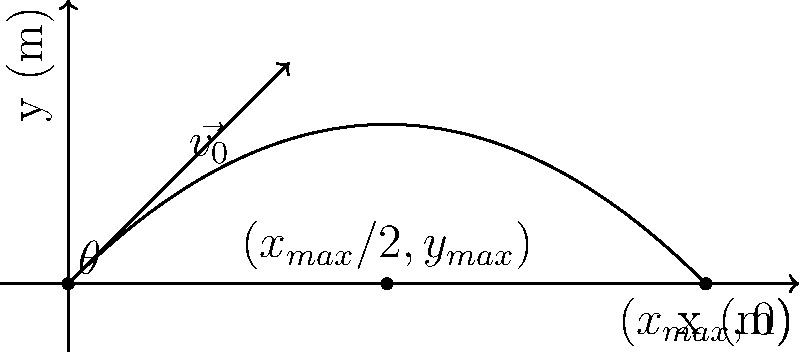A baseball player throws a ball with an initial velocity of 20 m/s at an angle of 45° above the horizontal. Assuming air resistance is negligible, determine:
a) The maximum height reached by the ball
b) The total horizontal distance traveled by the ball

Express your answers in meters, rounded to two decimal places. Let's approach this step-by-step:

1) First, we need to break down the initial velocity into its horizontal and vertical components:
   $v_{0x} = v_0 \cos(\theta) = 20 \cos(45°) = 20 \cdot \frac{\sqrt{2}}{2} \approx 14.14$ m/s
   $v_{0y} = v_0 \sin(\theta) = 20 \sin(45°) = 20 \cdot \frac{\sqrt{2}}{2} \approx 14.14$ m/s

2) To find the maximum height, we can use the equation:
   $y_{max} = \frac{v_{0y}^2}{2g}$
   Where $g$ is the acceleration due to gravity (9.8 m/s²)

   $y_{max} = \frac{(14.14)^2}{2(9.8)} \approx 10.20$ m

3) To find the total horizontal distance, we need to find the time of flight and then multiply it by the horizontal velocity:

   Time of flight: $t_{total} = \frac{2v_{0y}}{g} = \frac{2(14.14)}{9.8} \approx 2.89$ s

   Horizontal distance: $x_{max} = v_{0x} \cdot t_{total} = 14.14 \cdot 2.89 \approx 40.82$ m

Therefore, the maximum height is 10.20 m and the total horizontal distance is 40.82 m.
Answer: a) 10.20 m
b) 40.82 m 